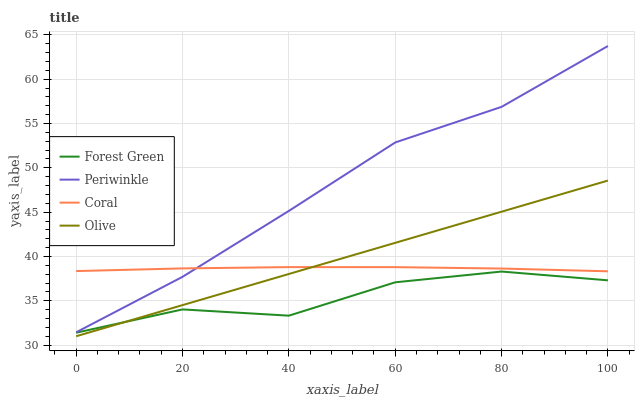Does Forest Green have the minimum area under the curve?
Answer yes or no. Yes. Does Periwinkle have the maximum area under the curve?
Answer yes or no. Yes. Does Periwinkle have the minimum area under the curve?
Answer yes or no. No. Does Forest Green have the maximum area under the curve?
Answer yes or no. No. Is Olive the smoothest?
Answer yes or no. Yes. Is Forest Green the roughest?
Answer yes or no. Yes. Is Periwinkle the smoothest?
Answer yes or no. No. Is Periwinkle the roughest?
Answer yes or no. No. Does Forest Green have the lowest value?
Answer yes or no. No. Does Periwinkle have the highest value?
Answer yes or no. Yes. Does Forest Green have the highest value?
Answer yes or no. No. Is Forest Green less than Periwinkle?
Answer yes or no. Yes. Is Periwinkle greater than Forest Green?
Answer yes or no. Yes. Does Olive intersect Coral?
Answer yes or no. Yes. Is Olive less than Coral?
Answer yes or no. No. Is Olive greater than Coral?
Answer yes or no. No. Does Forest Green intersect Periwinkle?
Answer yes or no. No. 